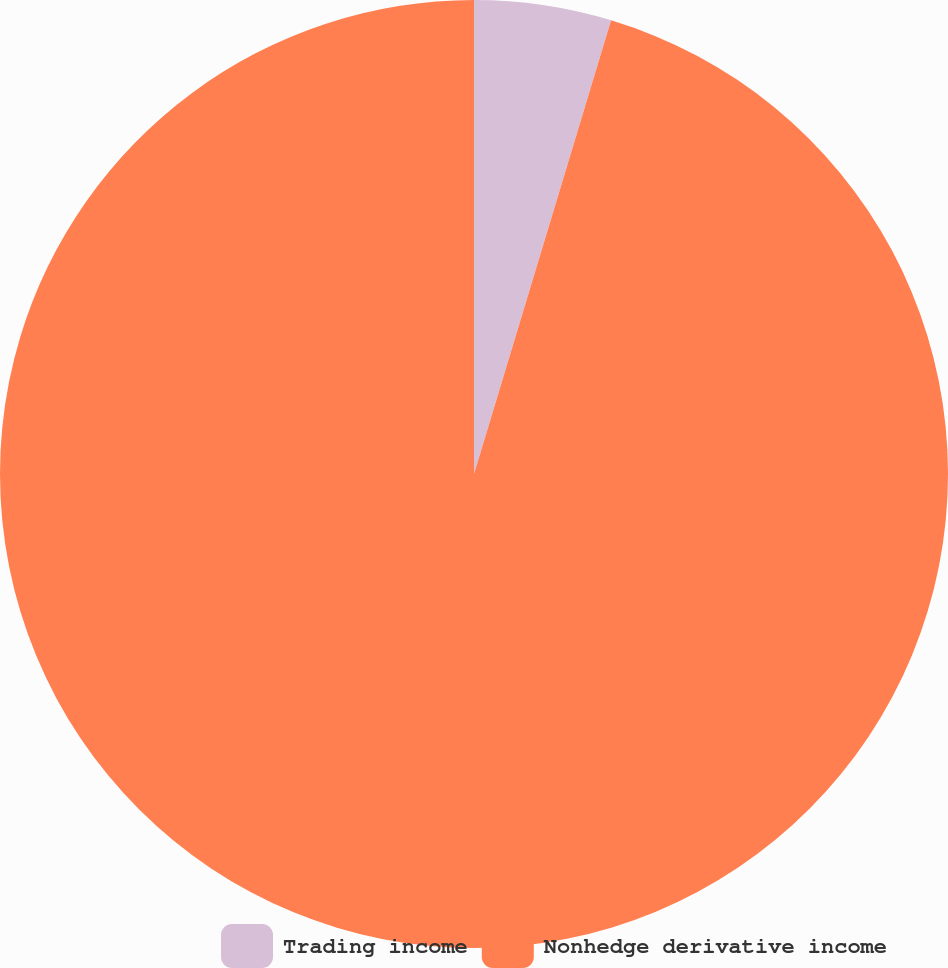Convert chart. <chart><loc_0><loc_0><loc_500><loc_500><pie_chart><fcel>Trading income<fcel>Nonhedge derivative income<nl><fcel>4.67%<fcel>95.33%<nl></chart> 